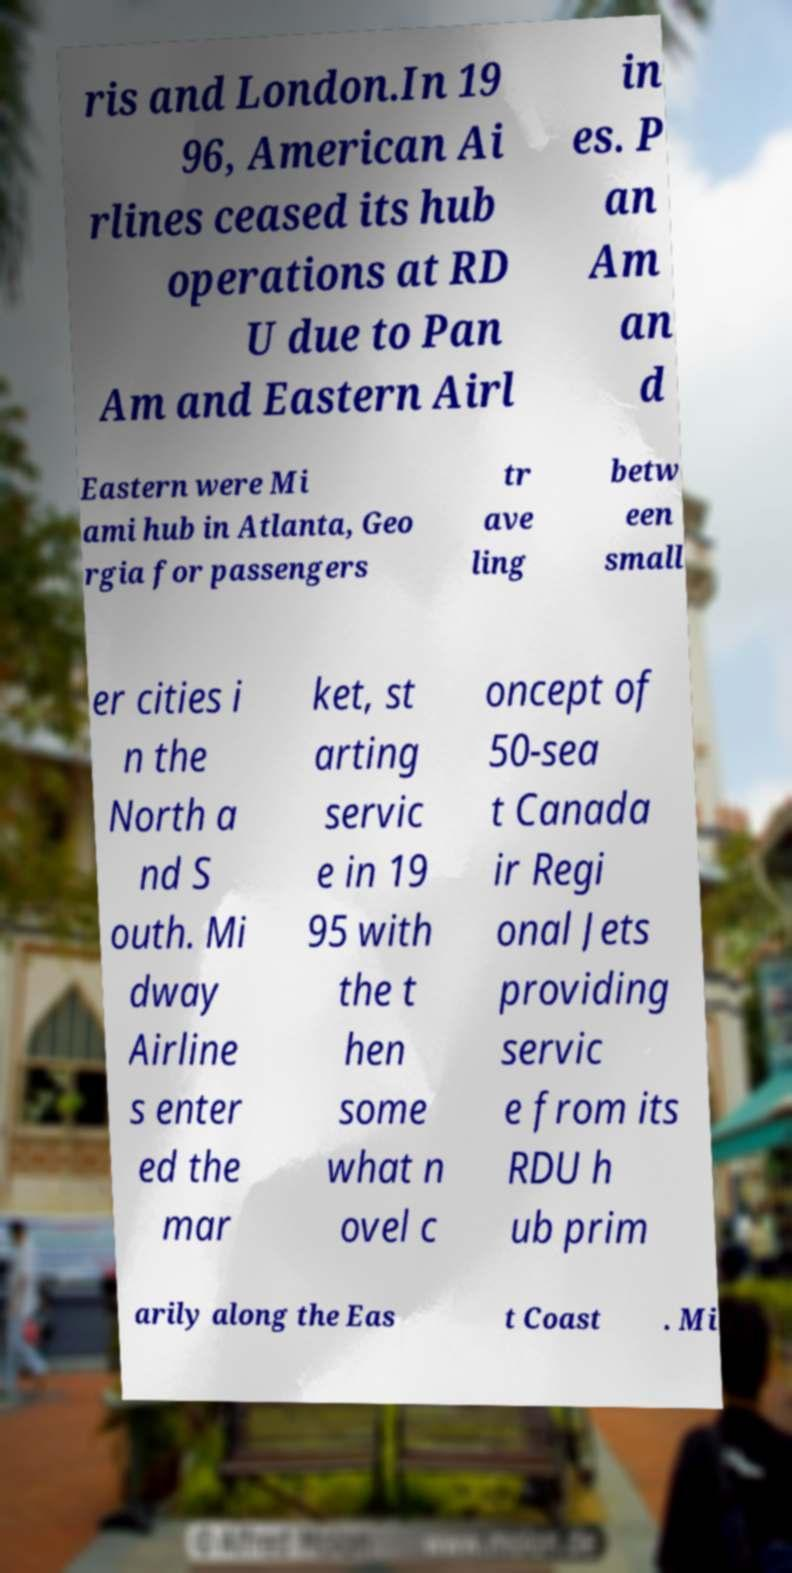Can you read and provide the text displayed in the image?This photo seems to have some interesting text. Can you extract and type it out for me? ris and London.In 19 96, American Ai rlines ceased its hub operations at RD U due to Pan Am and Eastern Airl in es. P an Am an d Eastern were Mi ami hub in Atlanta, Geo rgia for passengers tr ave ling betw een small er cities i n the North a nd S outh. Mi dway Airline s enter ed the mar ket, st arting servic e in 19 95 with the t hen some what n ovel c oncept of 50-sea t Canada ir Regi onal Jets providing servic e from its RDU h ub prim arily along the Eas t Coast . Mi 